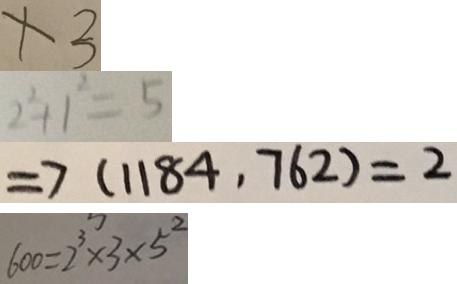Convert formula to latex. <formula><loc_0><loc_0><loc_500><loc_500>x 3 
 2 ^ { 2 } + 1 ^ { 2 } = 5 
 \Rightarrow ( 1 1 8 4 , 7 6 2 ) = 2 
 6 0 0 = 2 ^ { 3 } \times 3 \times 5 ^ { 2 }</formula> 